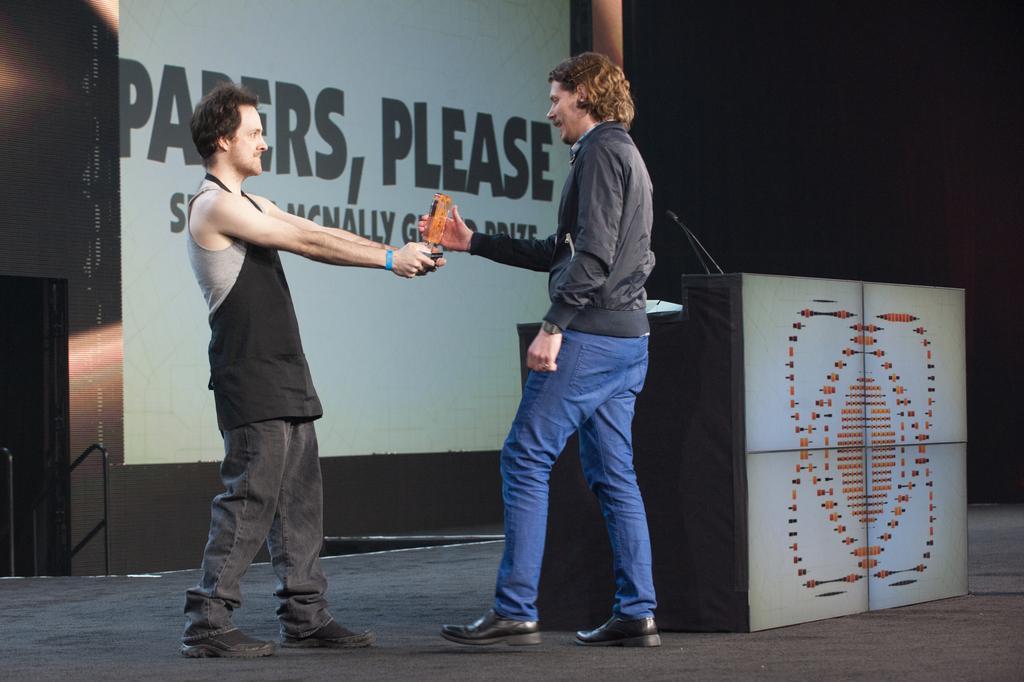Please provide a concise description of this image. In this image we can see two persons standing. We can also see a person holding the award. Image also consists of a podium and also the mike. We can also see the board with text. At the bottom there is stage. 